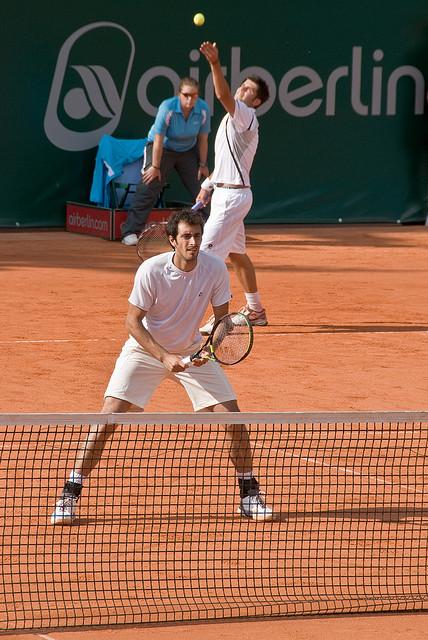Is the person playing tennis white or black?
Keep it brief. White. Is the man in the background also playing tennis?
Be succinct. Yes. What sport is this?
Give a very brief answer. Tennis. Is this man ready to play tennis?
Give a very brief answer. Yes. What color is the court's floor?
Quick response, please. Brown. How many people are on each team?
Concise answer only. 2. Is the man a pro?
Keep it brief. Yes. What is the job of the man in the gray pants?
Short answer required. Umpire. What is the tossing?
Answer briefly. Tennis ball. 